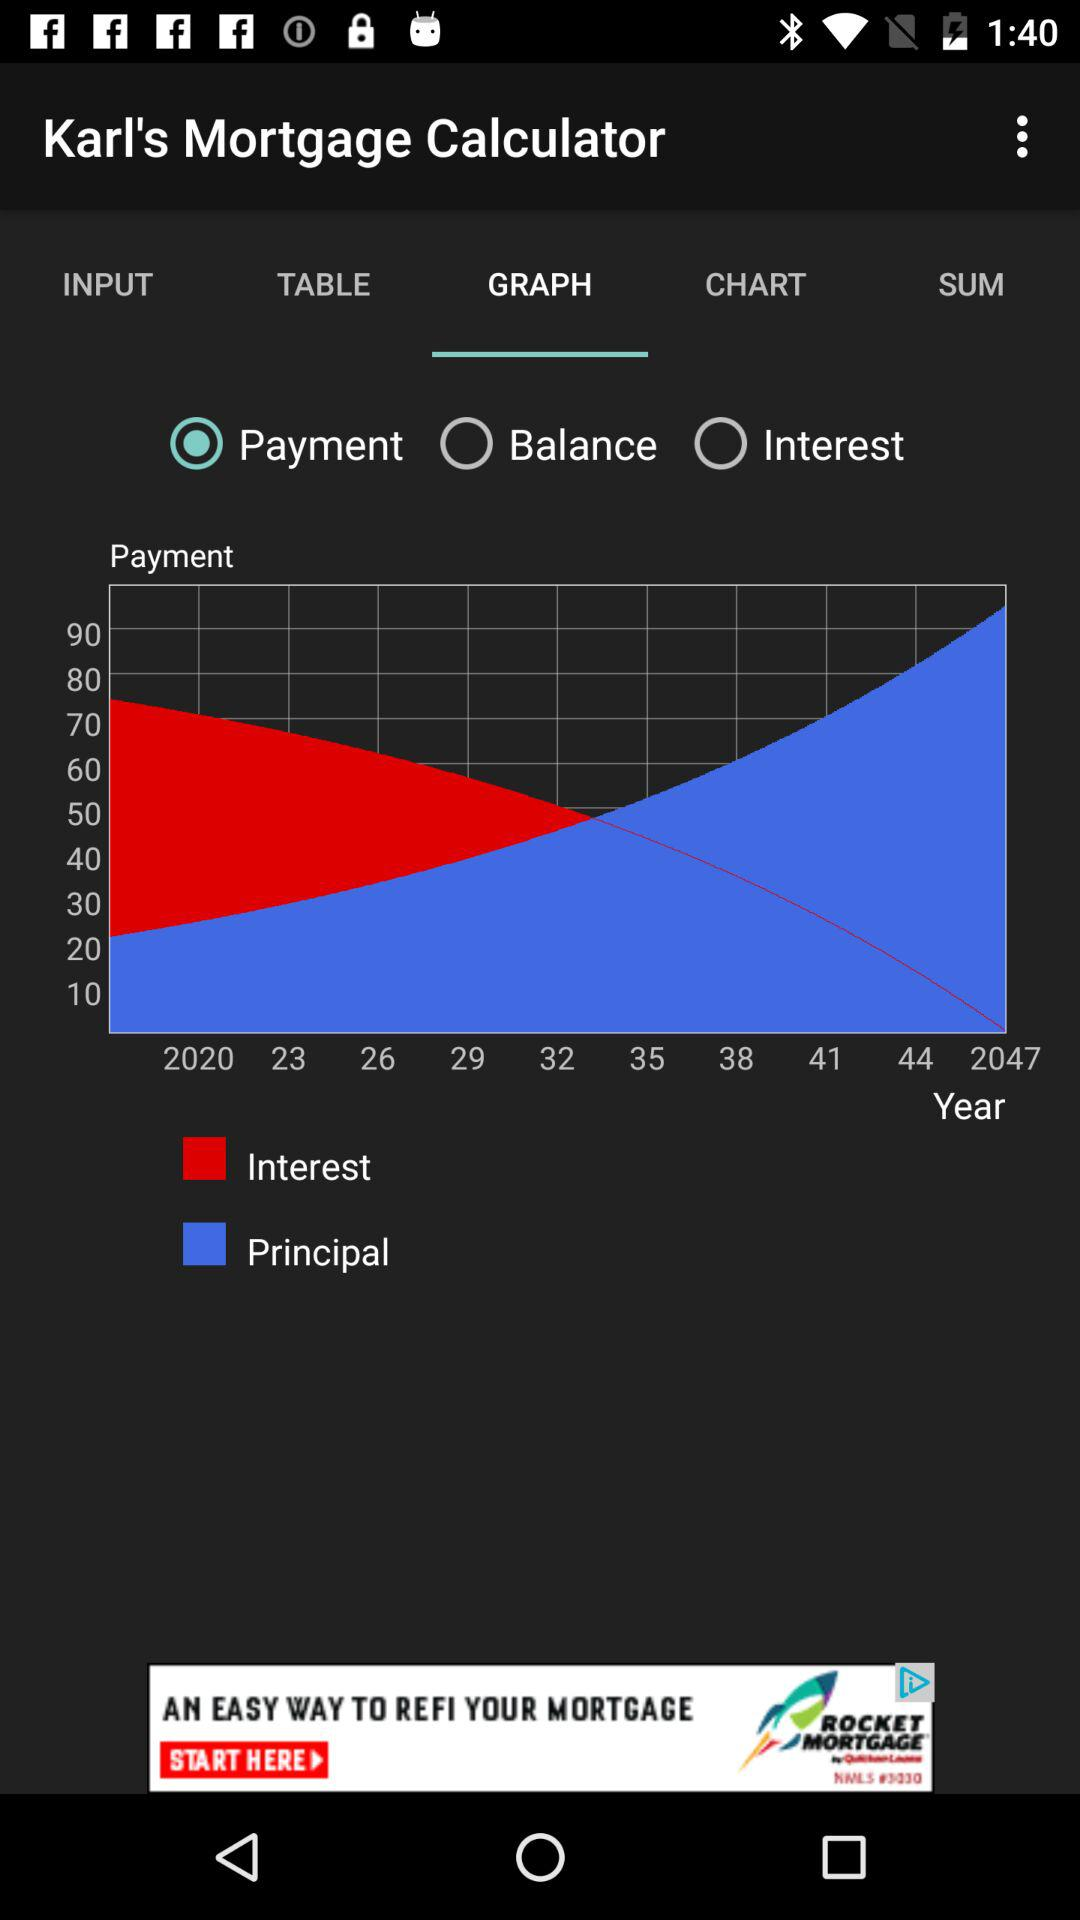Which tab is selected? The selected tab is "GRAPH". 